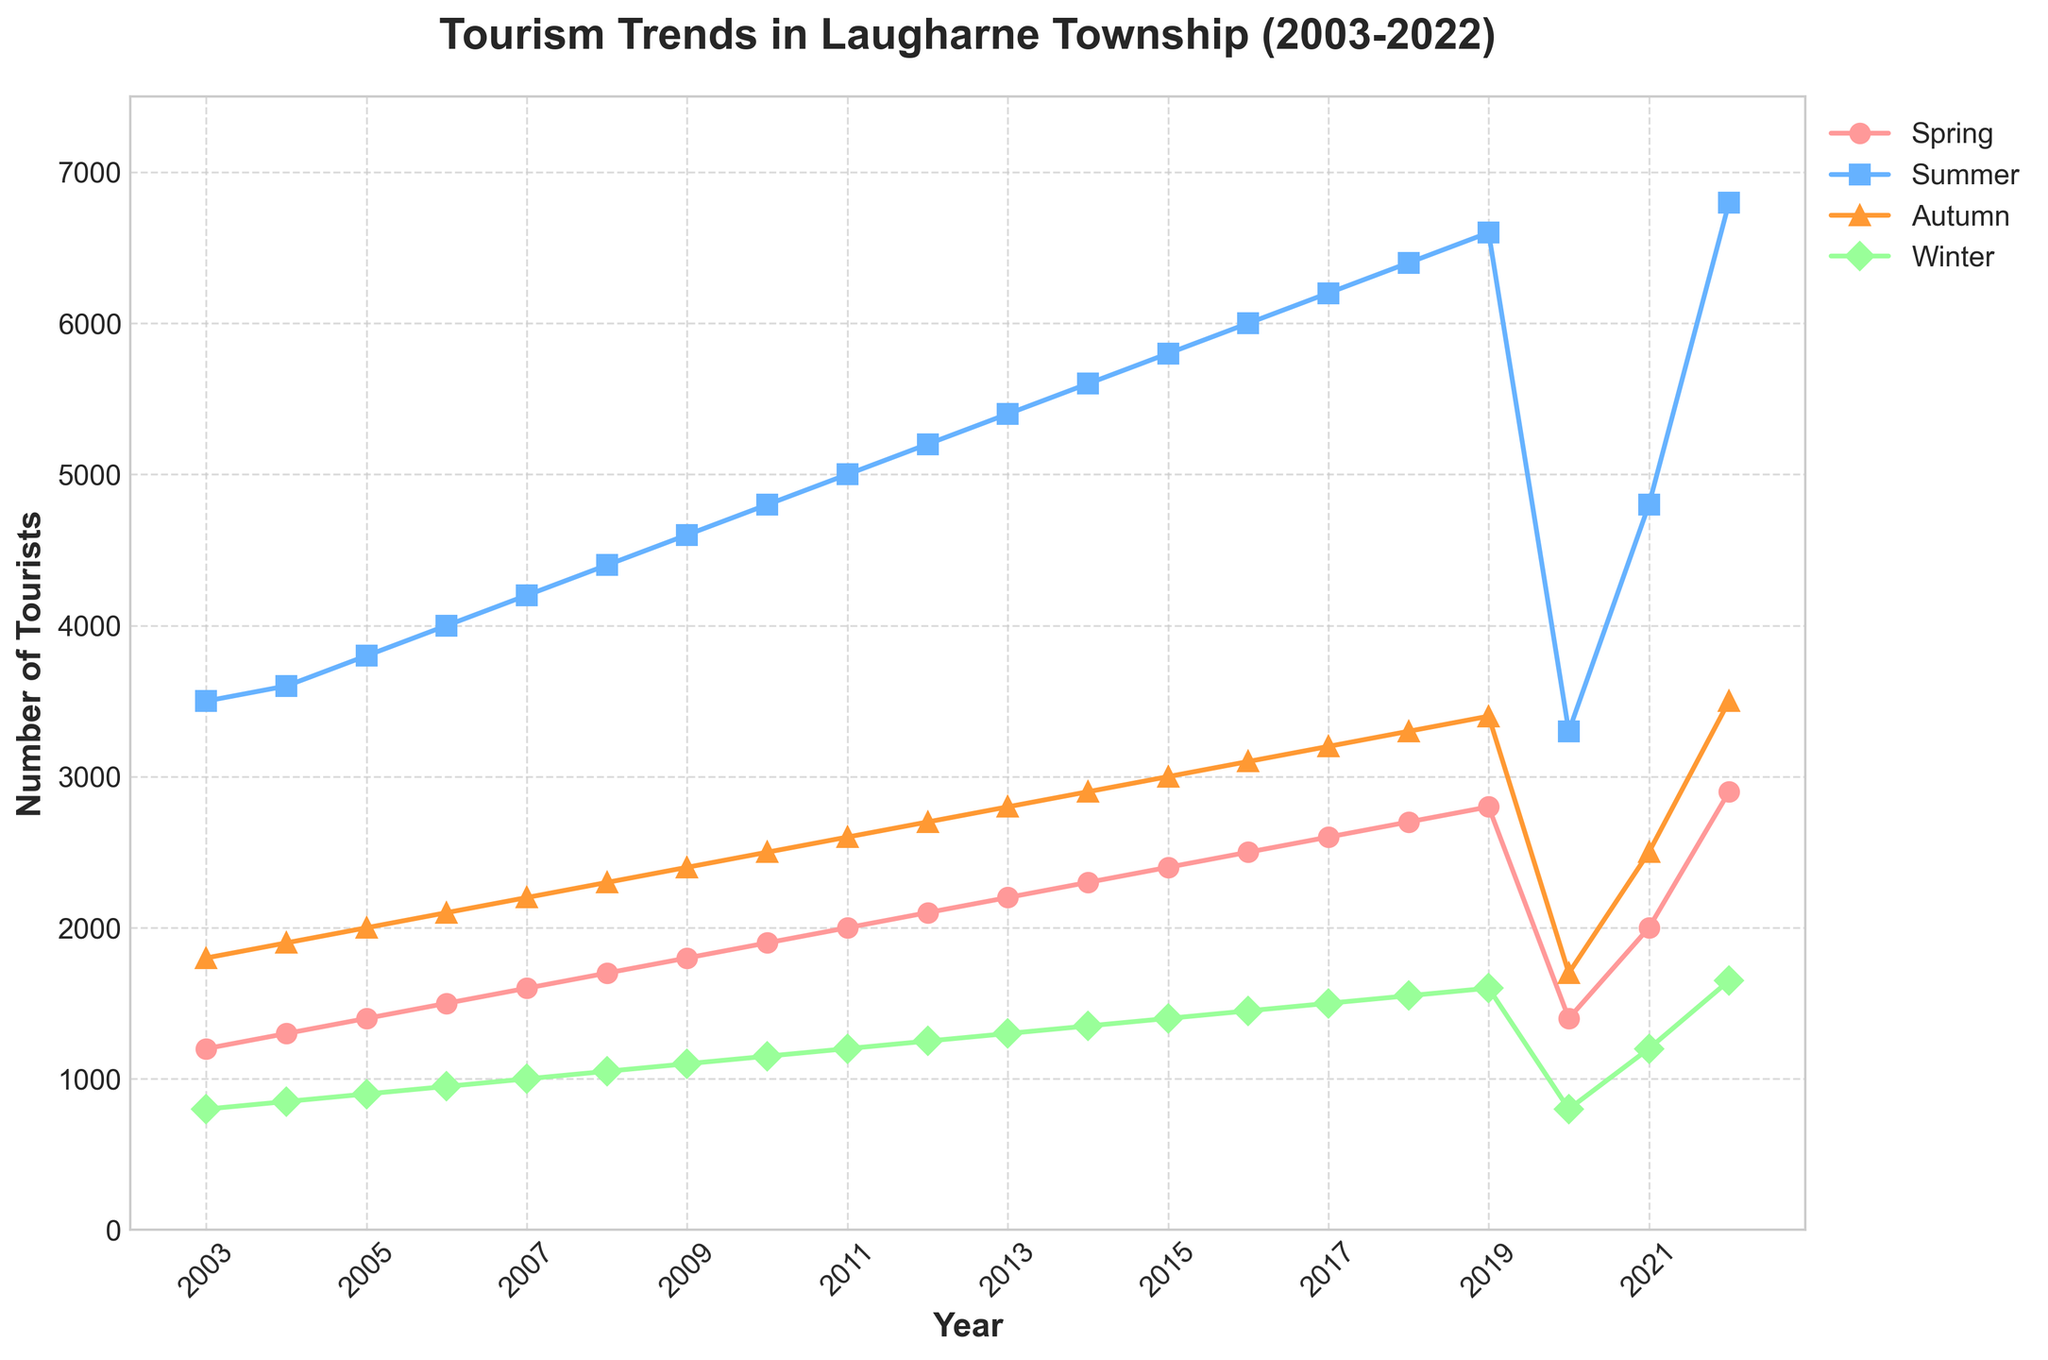What is the average number of tourists visiting in Spring over the 20-year period? Calculate the average by summing the Spring values and dividing by the number of years. Sum = (1200 + 1300 + 1400 + 1500 + 1600 + 1700 + 1800 + 1900 + 2000 + 2100 + 2200 + 2300 + 2400 + 2500 + 2600 + 2700 + 2800 + 1400 + 2000 + 2900) = 38800, Number of years = 20, Average = 38800 / 20 = 1940
Answer: 1940 Which season had the highest number of tourists in 2022? From the 2022 data points, Summer had 6800, Spring had 2900, Autumn had 3500, and Winter had 1650 tourists. The highest number is 6800 in Summer.
Answer: Summer How did the number of tourists in Winter in 2020 compare to Winter in 2021? In 2020, Winter had 800 tourists, and in 2021, it had 1200 tourists. 2021 had 400 more tourists than 2020.
Answer: 400 more in 2021 What is the percentage increase in tourists visiting in Summer from 2003 to 2022? The number of tourists in Summer 2003 was 3500, and in Summer 2022, it was 6800. Increase = 6800 - 3500 = 3300. Percentage increase = (3300 / 3500) * 100 = 94.29%
Answer: 94.29% Which season experienced the least growth over the period 2003 to 2022? Calculate the growth for each season from 2003 to 2022. Spring: (2900-1200) = 1700, Summer: (6800-3500) = 3300, Autumn: (3500-1800) = 1700, Winter: (1650-800) = 850. Winter experienced the least growth.
Answer: Winter What is the lowest number of tourists in any season over the past 20 years? By examining the data points, the lowest number of tourists in any season is 800 in Winter, occurring in 2003 and 2020.
Answer: 800 How has tourism in Spring changed from 2019 to 2020, and from 2020 to 2021? In 2019, Spring had 2800 tourists, in 2020, 1400 tourists, and in 2021, 2000 tourists. From 2019 to 2020, the change is 2800 - 1400 = -1400 (decrease). From 2020 to 2021, the change is 2000 - 1400 = 600 (increase).
Answer: -1400 from 2019 to 2020, 600 from 2020 to 2021 Which year had the most significant drop in the number of tourists for Summer compared to the previous year? Compare Summer values year by year. The significant drop was from 2019 (6600) to 2020 (3300), a decrease of 3300 tourists.
Answer: 2020 What was the trend of tourists visiting in Autumn from 2008 to 2012? Examine Autumn values from 2008 (2300), 2009 (2400), 2010 (2500), 2011 (2600), and 2012 (2700). The trend is a consistent increase every year.
Answer: Consistent increase Compare the number of tourists visiting in Winter in 2003 and 2022, and calculate the percentage change. In 2003, Winter had 800 tourists and in 2022, it had 1650 tourists. Increase = 1650 - 800 = 850. Percentage change = (850 / 800) * 100 = 106.25%
Answer: 106.25% 